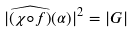Convert formula to latex. <formula><loc_0><loc_0><loc_500><loc_500>| \widehat { ( \chi \circ f ) } ( \alpha ) | ^ { 2 } = | G |</formula> 